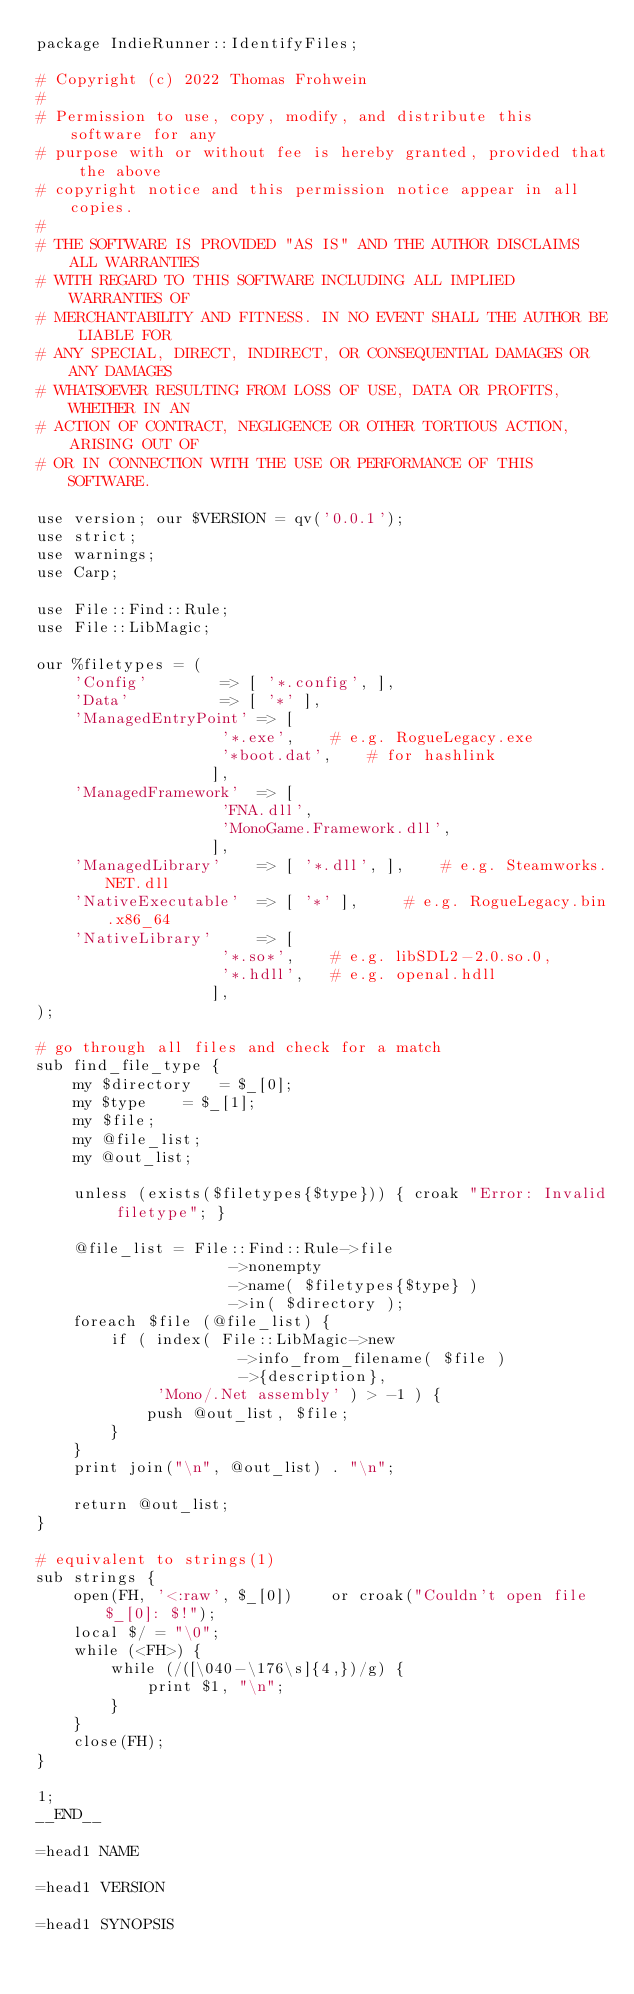Convert code to text. <code><loc_0><loc_0><loc_500><loc_500><_Perl_>package IndieRunner::IdentifyFiles;

# Copyright (c) 2022 Thomas Frohwein
#
# Permission to use, copy, modify, and distribute this software for any
# purpose with or without fee is hereby granted, provided that the above
# copyright notice and this permission notice appear in all copies.
#
# THE SOFTWARE IS PROVIDED "AS IS" AND THE AUTHOR DISCLAIMS ALL WARRANTIES
# WITH REGARD TO THIS SOFTWARE INCLUDING ALL IMPLIED WARRANTIES OF
# MERCHANTABILITY AND FITNESS. IN NO EVENT SHALL THE AUTHOR BE LIABLE FOR
# ANY SPECIAL, DIRECT, INDIRECT, OR CONSEQUENTIAL DAMAGES OR ANY DAMAGES
# WHATSOEVER RESULTING FROM LOSS OF USE, DATA OR PROFITS, WHETHER IN AN
# ACTION OF CONTRACT, NEGLIGENCE OR OTHER TORTIOUS ACTION, ARISING OUT OF
# OR IN CONNECTION WITH THE USE OR PERFORMANCE OF THIS SOFTWARE.

use version; our $VERSION = qv('0.0.1');
use strict;
use warnings;
use Carp;

use File::Find::Rule;
use File::LibMagic;

our %filetypes = (
	'Config'		=> [ '*.config', ],
	'Data'			=> [ '*' ],
	'ManagedEntryPoint'	=> [
					'*.exe',	# e.g. RogueLegacy.exe
					'*boot.dat',	# for hashlink
				   ],
	'ManagedFramework'	=> [
					'FNA.dll',
					'MonoGame.Framework.dll',
				   ],
	'ManagedLibrary'	=> [ '*.dll', ],	# e.g. Steamworks.NET.dll
	'NativeExecutable'	=> [ '*' ],		# e.g. RogueLegacy.bin.x86_64
	'NativeLibrary'		=> [
					'*.so*',	# e.g. libSDL2-2.0.so.0, 
					'*.hdll',	# e.g. openal.hdll
				   ],
);

# go through all files and check for a match
sub find_file_type {
	my $directory	= $_[0];
	my $type	= $_[1];
	my $file;
	my @file_list;
	my @out_list;

	unless (exists($filetypes{$type})) { croak "Error: Invalid filetype"; }

	@file_list = File::Find::Rule->file
				     ->nonempty
				     ->name( $filetypes{$type} )
				     ->in( $directory );
	foreach $file (@file_list) {
		if ( index( File::LibMagic->new
					  ->info_from_filename( $file )
					  ->{description},
		     'Mono/.Net assembly' ) > -1 ) {
			push @out_list, $file;
		}
	}
	print join("\n", @out_list) . "\n";
	
	return @out_list;
}

# equivalent to strings(1)
sub strings {
	open(FH, '<:raw', $_[0])	or croak("Couldn't open file $_[0]: $!");
	local $/ = "\0";
	while (<FH>) {
		while (/([\040-\176\s]{4,})/g) {
			print $1, "\n";
		}
	}
	close(FH);
}

1;
__END__

=head1 NAME

=head1 VERSION

=head1 SYNOPSIS
</code> 